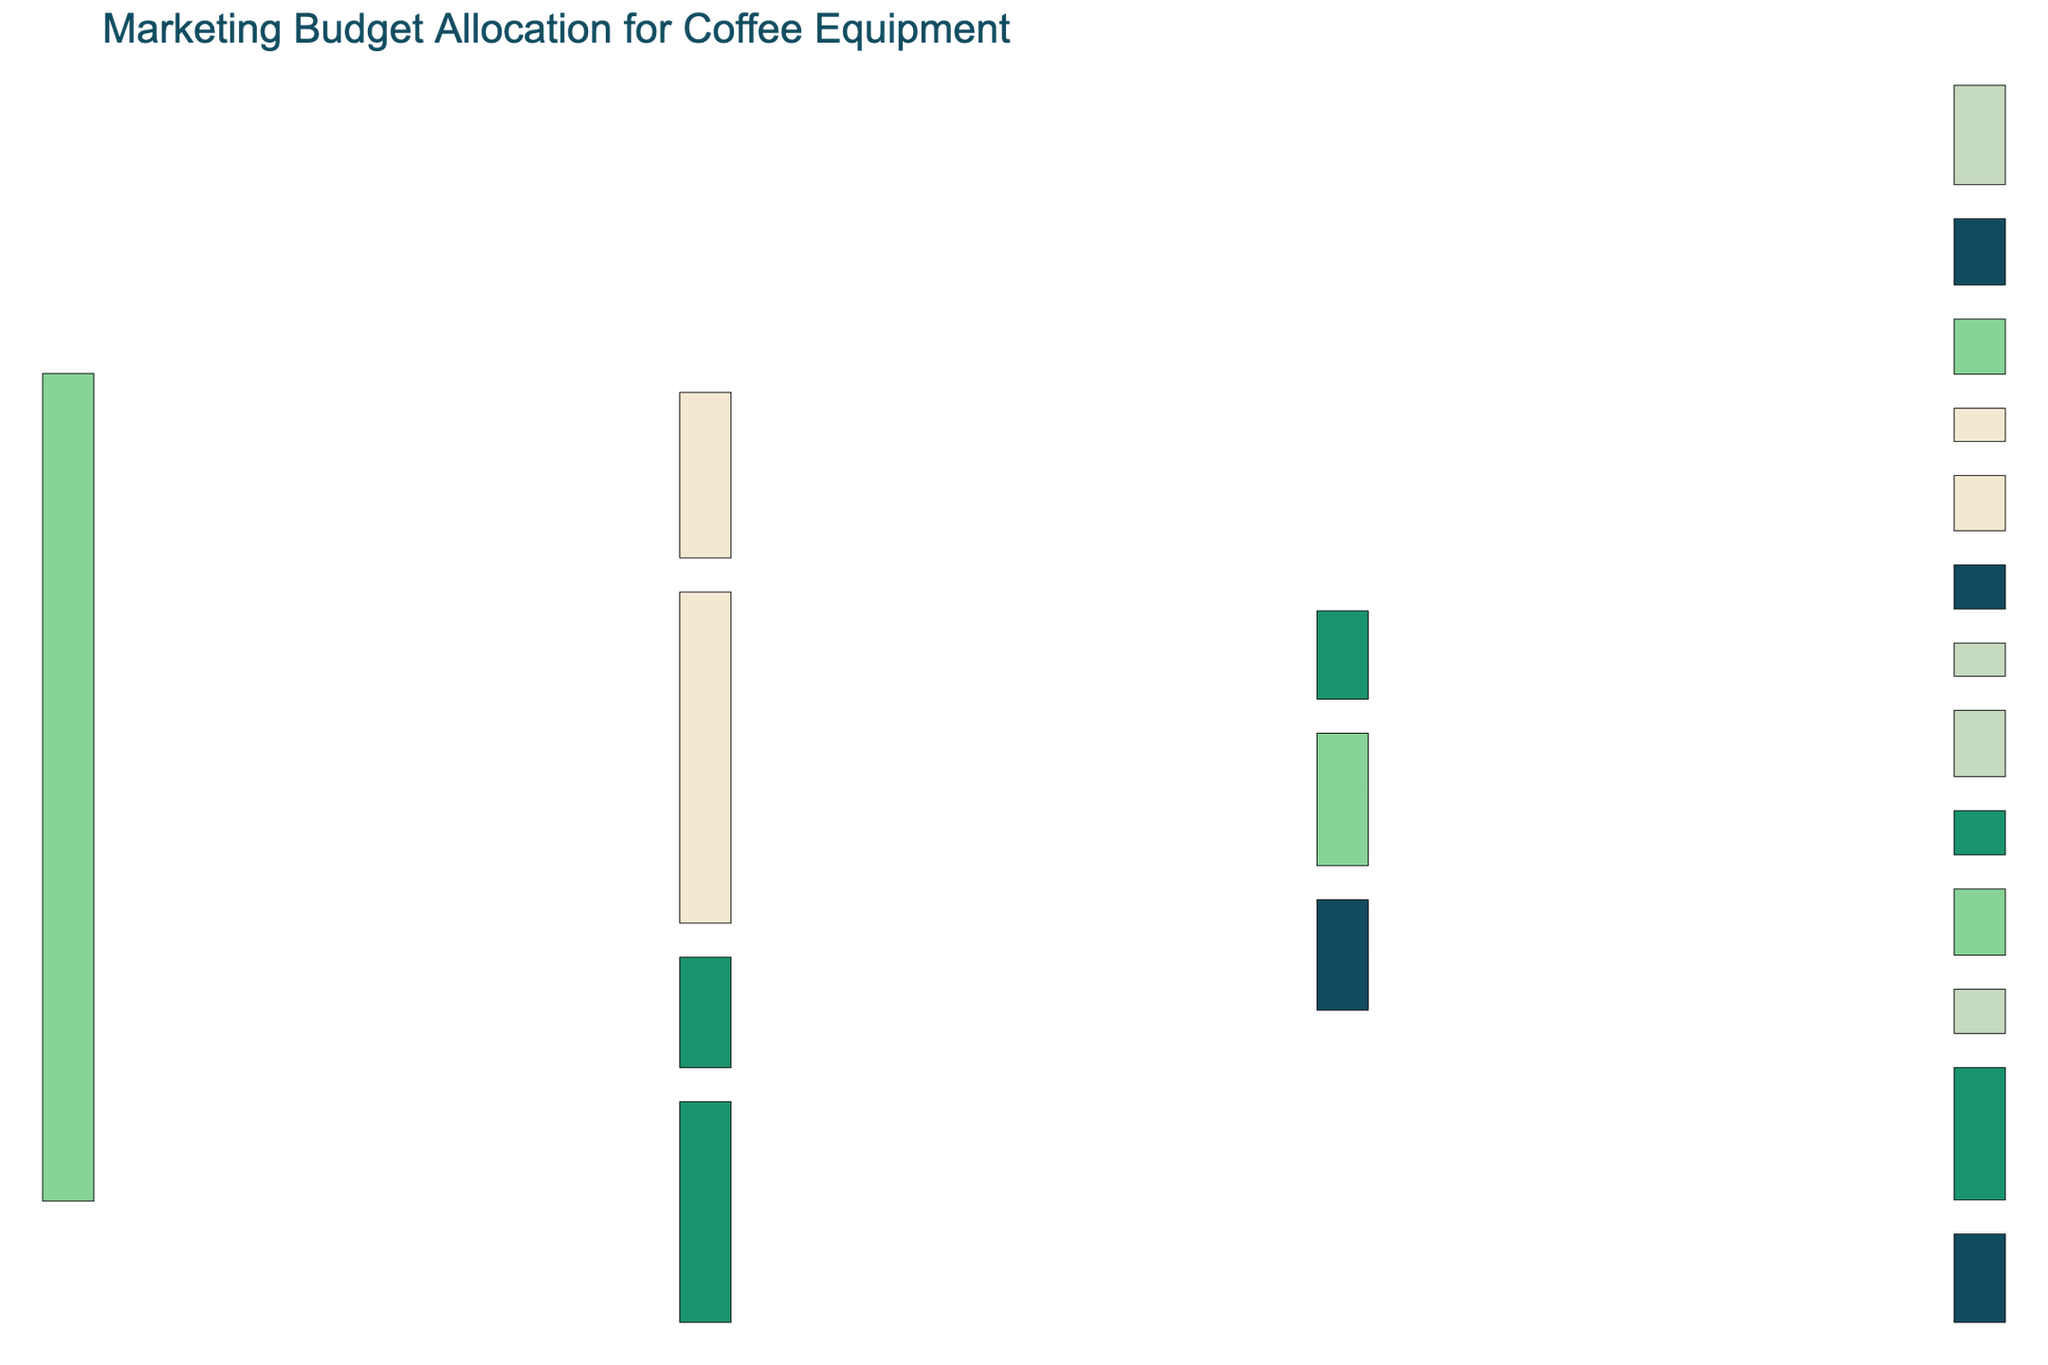What's the title of the figure? The title is generally placed at the top of the figure. The title indicates the main subject of the diagram.
Answer: Marketing Budget Allocation for Coffee Equipment Which promotional channel received the highest total budget? By tracing the connections from the "Total Budget" node, we observe the values connected to each promotional channel. The "Digital Marketing" node has the highest value at 150,000.
Answer: Digital Marketing How much money was allocated from "Print Advertising" to "Coffee Industry Magazines"? Follow the connection from "Print Advertising" to "Coffee Industry Magazines" and observe the numerical value associated with that connection.
Answer: 30,000 What is the total budget allocation for "Influencer Partnerships"? Add the values from "Influencer Partnerships" to both "Coffee Bloggers" and "Barista Influencers" nodes. The values are 45,000 and 30,000.
Answer: 75,000 Which social media platform received the most funds from "Social Media Ads"? Trace the links from "Social Media Ads" and compare the values for Facebook, Instagram, and LinkedIn. Facebook receives the highest allocation at 25,000.
Answer: Facebook What is the difference in budget allocation between "Coffee Expo" and "Barista Championships"? Subtract the value allocated to the "Barista Championships" from the value allocated to the "Coffee Expo". The values are 60,000 for "Coffee Expo" and 40,000 for "Barista Championships".
Answer: 20,000 How much total budget was allocated to digital advertising channels (combining Social Media Ads, Google Ads, and Email Campaigns)? Sum all the values allocated to each type of digital advertising: Social Media Ads (60,000), Google Ads (50,000), and Email Campaigns (40,000). The total is 60,000 + 50,000 + 40,000.
Answer: 150,000 How is the "Email Campaigns" budget subdivided? Observe the connections from "Email Campaigns" to "Newsletter" and "Promotional Offers". The respective values are 25,000 and 15,000.
Answer: Newsletter: 25,000, Promotional Offers: 15,000 Which promotional channel received the lowest overall budget? Compare the allocations for each channel directly connected to the "Total Budget" node. "Print Advertising" has the lowest allocation at 50,000.
Answer: Print Advertising How are the budgets for "Google Ads" divided between "Search" and "Display"? Follow the connections from "Google Ads" to "Search" and "Display", and observe their respective values of 30,000 and 20,000.
Answer: Search: 30,000, Display: 20,000 